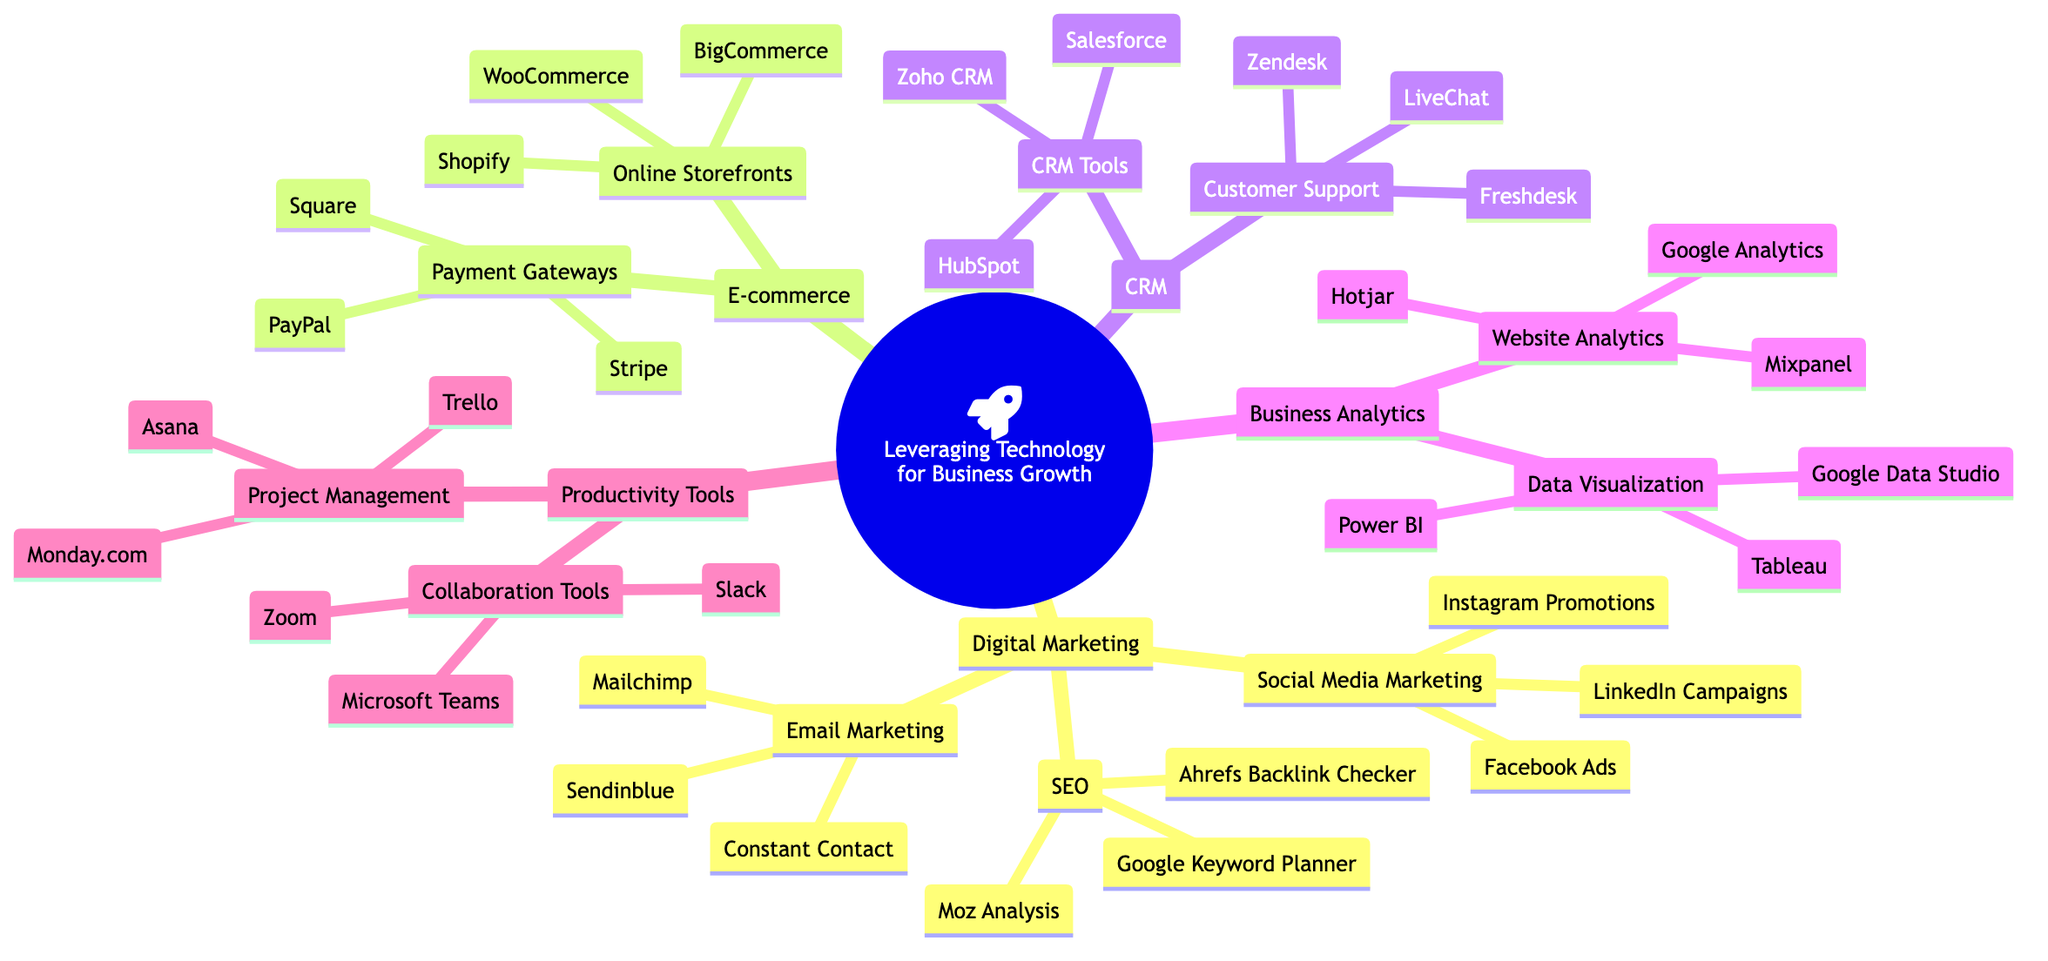What are the three main categories under "Leveraging Technology for Business Growth"? The three main categories listed in the mind map are Digital Marketing, E-commerce, and Customer Relationship Management (CRM).
Answer: Digital Marketing, E-commerce, Customer Relationship Management How many tools are listed under "Digital Marketing"? The "Digital Marketing" category includes three subcategories: Social Media Marketing, SEO, and Email Marketing. Each of these has additional tools listed, totaling nine tools when counted.
Answer: 9 Which platform is mentioned for online storefronts? The subcategory "Online Storefronts" under "E-commerce" lists three platforms: Shopify, WooCommerce, and BigCommerce. Here, Shopify is one of them.
Answer: Shopify What is the common function of the tools listed under "Customer Support"? The tools listed under "Customer Support" in the CRM category focus on enhancing customer service and support experiences. This includes tools like Zendesk, Freshdesk, and LiveChat, which are all designed for customer assistance.
Answer: Enhancing customer service Which tool is part of both "Data Visualization" and "Business Analytics"? Tableau is listed under "Data Visualization" as part of the "Business Analytics" category, demonstrating its integration in presenting analytical data visually.
Answer: Tableau Identify the payment gateways mentioned for e-commerce solutions. The "Payment Gateways" subcategory includes three solutions: PayPal, Stripe, and Square, each enabling seamless online transactions for e-commerce.
Answer: PayPal, Stripe, Square How many collaboration tools are listed? In the "Collaboration Tools" subcategory under "Productivity Tools," there are three listed tools: Slack, Microsoft Teams, and Zoom, which facilitate team communication and collaboration.
Answer: 3 Which marketing strategy is emphasized under "Social Media Marketing"? The "Social Media Marketing" subcategory emphasizes various strategies including Facebook Ads, Instagram Promotions, and LinkedIn Campaigns for maximizing online presence through social platforms.
Answer: Facebook Ads, Instagram Promotions, LinkedIn Campaigns What could be used to analyze website traffic? The "Website Analytics" subcategory under "Business Analytics" provides tools such as Google Analytics, Mixpanel, and Hotjar, which are specifically for analyzing website traffic and user behavior.
Answer: Google Analytics, Mixpanel, Hotjar 